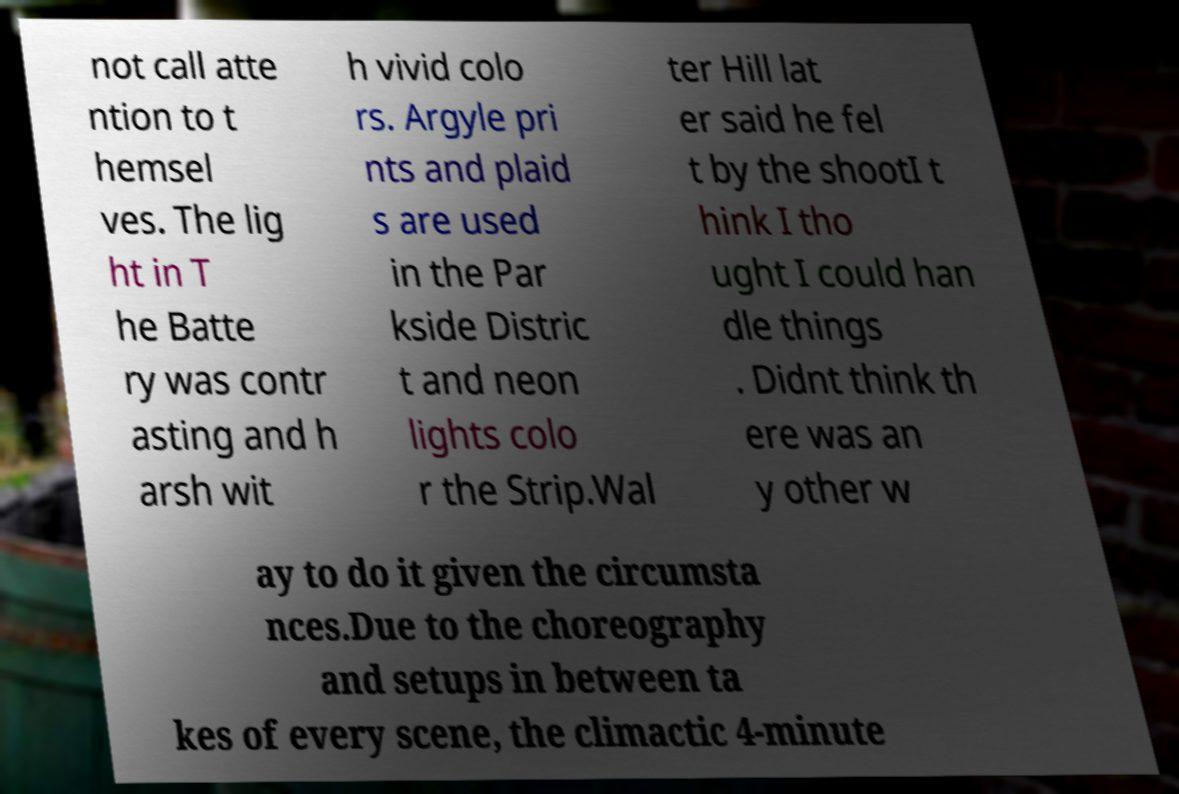Can you read and provide the text displayed in the image?This photo seems to have some interesting text. Can you extract and type it out for me? not call atte ntion to t hemsel ves. The lig ht in T he Batte ry was contr asting and h arsh wit h vivid colo rs. Argyle pri nts and plaid s are used in the Par kside Distric t and neon lights colo r the Strip.Wal ter Hill lat er said he fel t by the shootI t hink I tho ught I could han dle things . Didnt think th ere was an y other w ay to do it given the circumsta nces.Due to the choreography and setups in between ta kes of every scene, the climactic 4-minute 